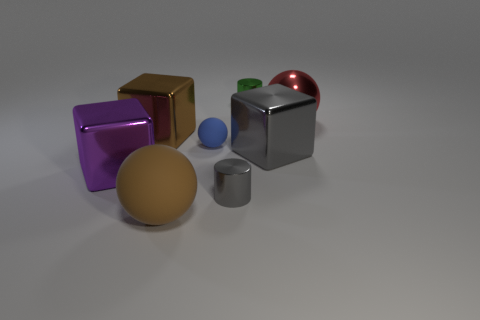Add 1 brown rubber cylinders. How many objects exist? 9 Subtract all cylinders. How many objects are left? 6 Subtract all large brown rubber objects. Subtract all purple metallic cubes. How many objects are left? 6 Add 1 large purple metal objects. How many large purple metal objects are left? 2 Add 2 large purple shiny balls. How many large purple shiny balls exist? 2 Subtract 0 yellow cubes. How many objects are left? 8 